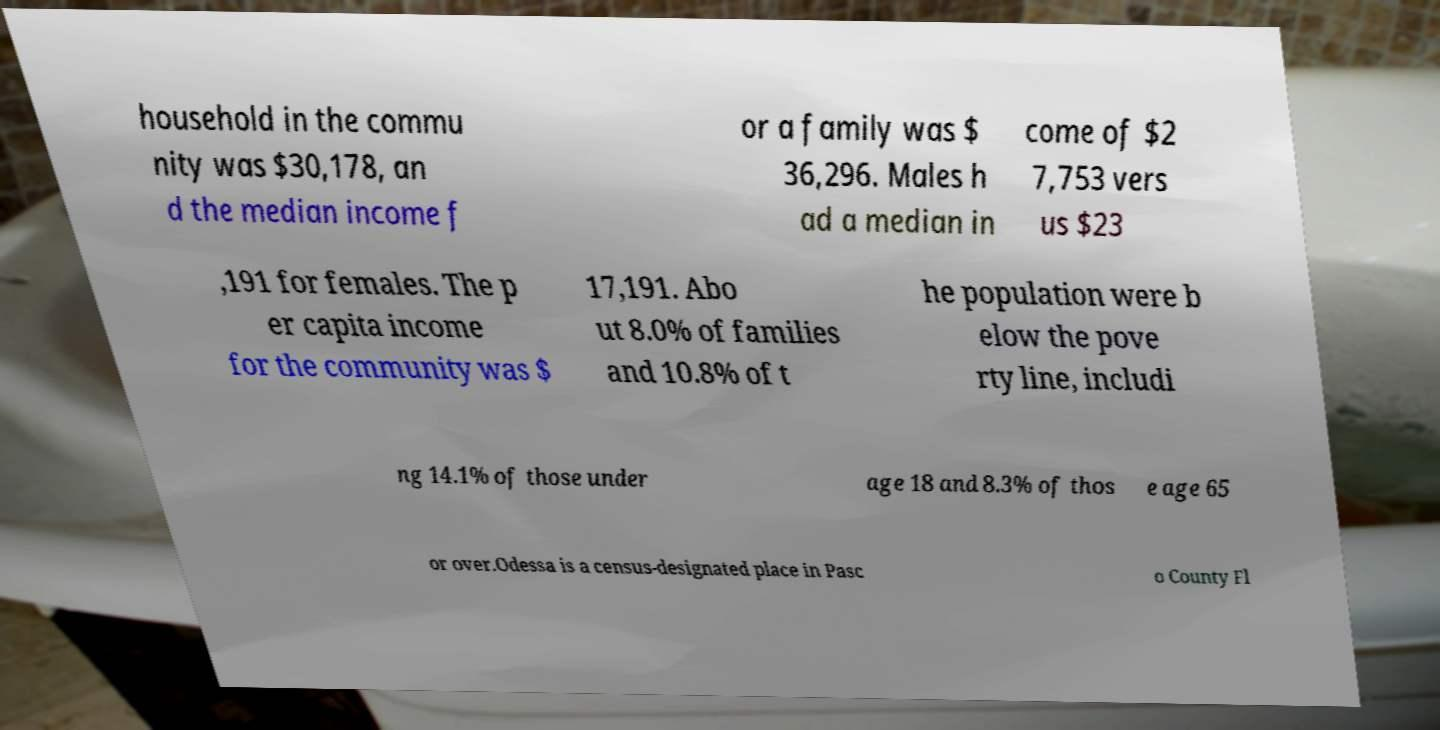Please identify and transcribe the text found in this image. household in the commu nity was $30,178, an d the median income f or a family was $ 36,296. Males h ad a median in come of $2 7,753 vers us $23 ,191 for females. The p er capita income for the community was $ 17,191. Abo ut 8.0% of families and 10.8% of t he population were b elow the pove rty line, includi ng 14.1% of those under age 18 and 8.3% of thos e age 65 or over.Odessa is a census-designated place in Pasc o County Fl 